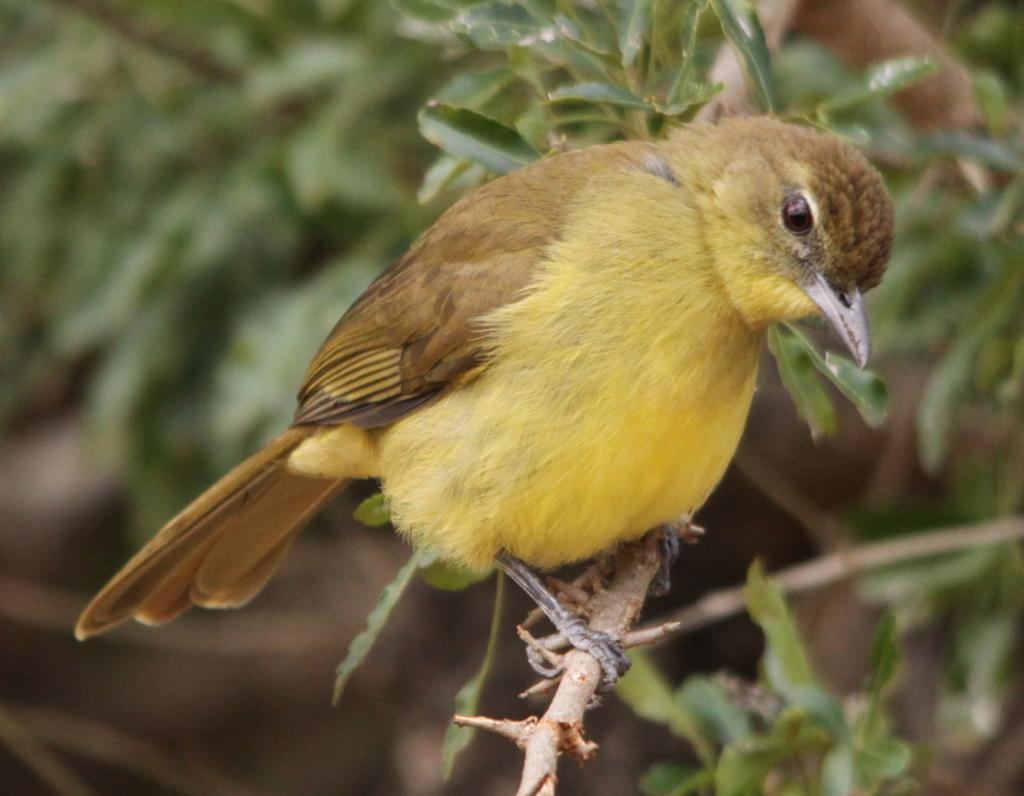Could you give a brief overview of what you see in this image? In this image I can see a bird is sitting on the branch. It is in yellow,brown and black color. I can see green color leaves. 